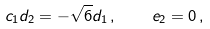<formula> <loc_0><loc_0><loc_500><loc_500>c _ { 1 } d _ { 2 } = - \sqrt { 6 } d _ { 1 } \, , \quad e _ { 2 } = 0 \, ,</formula> 